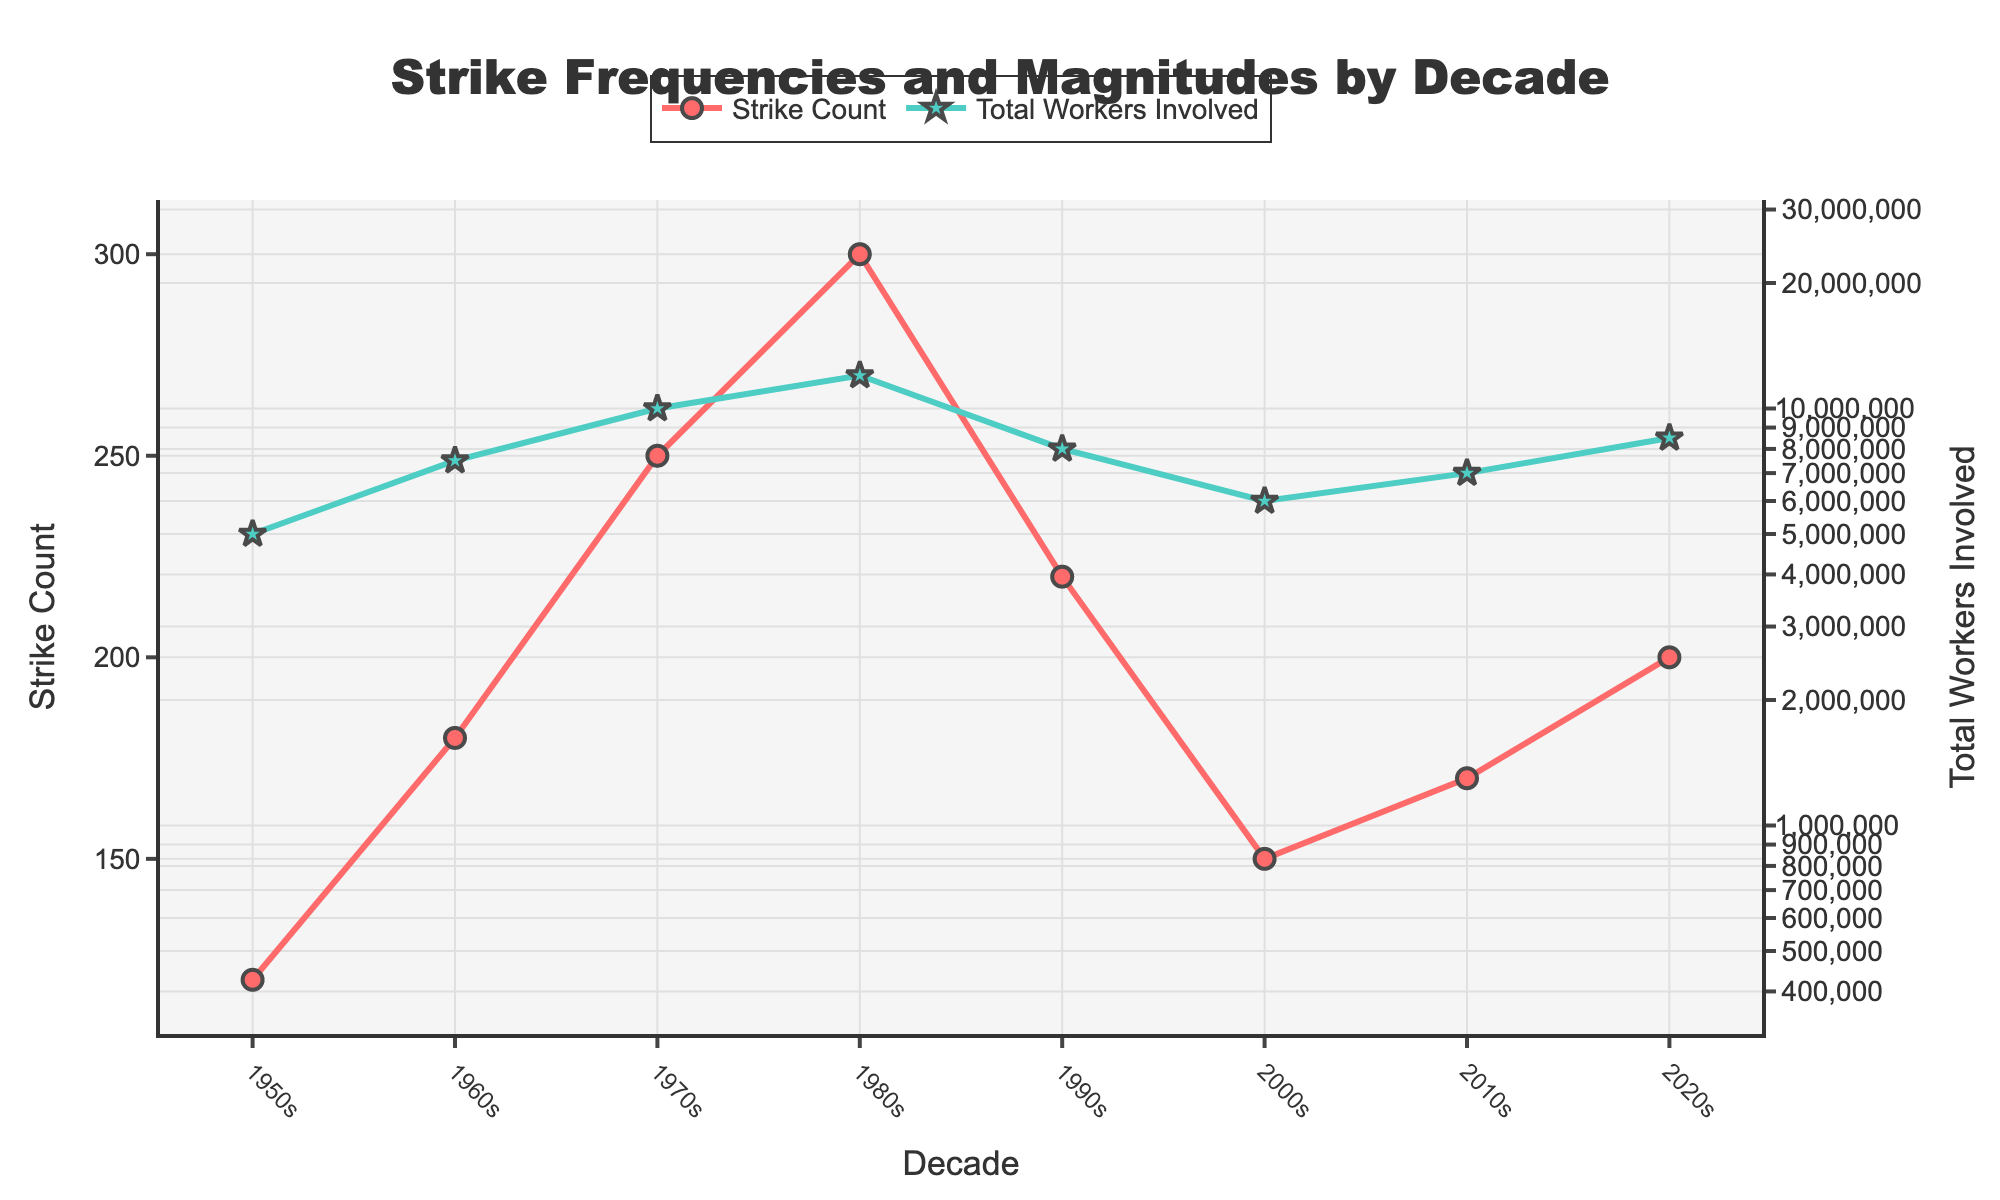what is the title of the plot? The title of the plot is displayed at the top and centered, written in bold. The figure is about strike data across decades.
Answer: Strike Frequencies and Magnitudes by Decade How many decades of data are displayed on the plot? Look at the x-axis, it lists the decades starting from the 1950s to the 2020s. Count them one-by-one.
Answer: 8 What color represents the 'Strike Count' line? Look at the legend or the line itself. The 'Strike Count' line has a distinct color different from 'Total Workers Involved'.
Answer: Red What is the highest 'Strike Count' observed in any decade, and in which decade did it occur? Observe the peak value of the red line and note the corresponding decade on the x-axis.
Answer: 300 in the 1980s How does the 'Total Workers Involved' compare between the 2000s and 2020s? Identify the values on the log scale axis for both the 2000s and 2020s and compare them.
Answer: Higher in the 2020s What's the average number of strikes per decade from 1980s to 2020s? Add the 'Strike Count' values for these decades and divide by the number of decades (4). Count: 300 + 220 + 150 + 200 = 870, divide by 4.
Answer: 217.5 Which decade experienced the largest decline in 'Strike Count' compared to its previous decade? Calculate the difference in 'Strike Count' between consecutive decades and identify the largest drop. 1980s to 1990s: 300-220=80.
Answer: 1980s to 1990s What's the difference in 'Total Workers Involved' between the 1970s and 2010s? Find the 'Total Workers Involved' values for both decades and subtract the smaller from the larger. 10,000,000 - 7,000,000.
Answer: 3,000,000 Is there any decade where both 'Strike Count' and 'Total Workers Involved' decreased compared to the previous decade? Check both lines for any pair of consecutive decades where both values show a drop.
Answer: 1980s to 1990s 